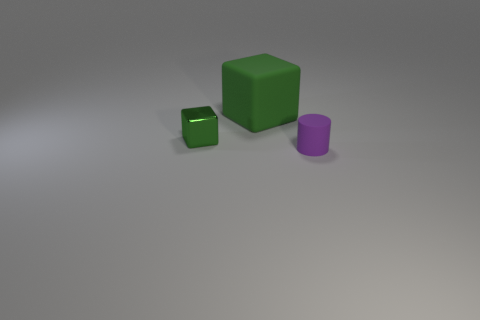Are there any other things that have the same material as the small green cube?
Ensure brevity in your answer.  No. There is another thing that is the same shape as the large green rubber object; what is its material?
Make the answer very short. Metal. What color is the matte cylinder?
Provide a short and direct response. Purple. There is a object that is on the left side of the matte object that is to the left of the purple matte cylinder; what is its color?
Your answer should be compact. Green. There is a big rubber block; is its color the same as the block that is on the left side of the big green block?
Your answer should be very brief. Yes. How many purple cylinders are in front of the green thing in front of the block that is behind the small green shiny thing?
Provide a succinct answer. 1. Are there any tiny green objects in front of the big green matte block?
Offer a terse response. Yes. Is there anything else that has the same color as the tiny rubber cylinder?
Keep it short and to the point. No. What number of blocks are either large objects or tiny metallic objects?
Give a very brief answer. 2. What number of objects are both to the left of the small rubber cylinder and in front of the large green object?
Make the answer very short. 1. 